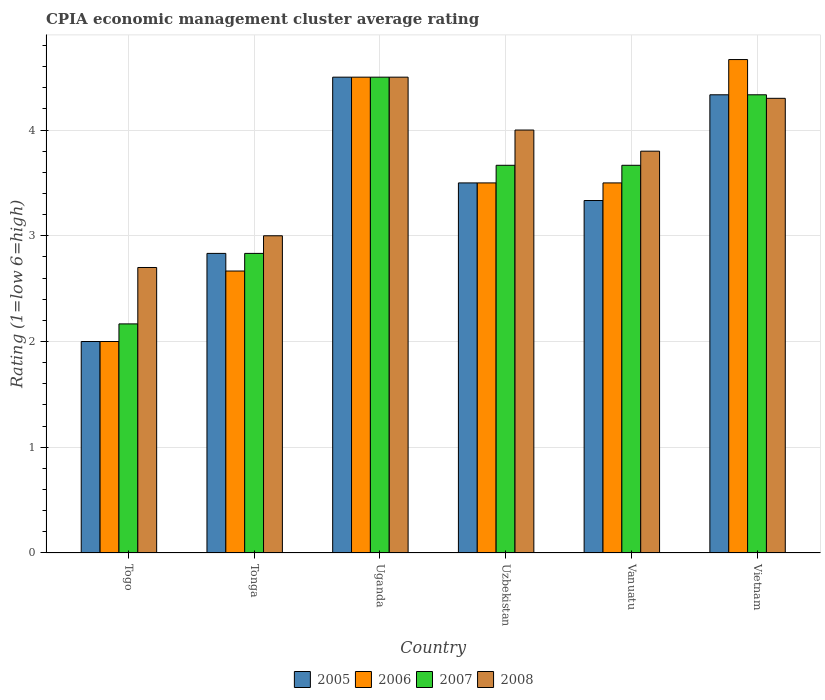Are the number of bars per tick equal to the number of legend labels?
Offer a terse response. Yes. How many bars are there on the 6th tick from the right?
Make the answer very short. 4. What is the label of the 6th group of bars from the left?
Offer a terse response. Vietnam. In how many cases, is the number of bars for a given country not equal to the number of legend labels?
Provide a short and direct response. 0. What is the CPIA rating in 2005 in Vietnam?
Offer a terse response. 4.33. Across all countries, what is the minimum CPIA rating in 2007?
Make the answer very short. 2.17. In which country was the CPIA rating in 2007 maximum?
Your response must be concise. Uganda. In which country was the CPIA rating in 2008 minimum?
Offer a terse response. Togo. What is the total CPIA rating in 2007 in the graph?
Your answer should be very brief. 21.17. What is the difference between the CPIA rating in 2007 in Uganda and that in Vietnam?
Your response must be concise. 0.17. What is the difference between the CPIA rating in 2006 in Vietnam and the CPIA rating in 2005 in Togo?
Give a very brief answer. 2.67. What is the average CPIA rating in 2005 per country?
Your answer should be compact. 3.42. What is the difference between the CPIA rating of/in 2006 and CPIA rating of/in 2007 in Uzbekistan?
Offer a terse response. -0.17. What is the ratio of the CPIA rating in 2007 in Tonga to that in Vanuatu?
Your response must be concise. 0.77. Is the difference between the CPIA rating in 2006 in Tonga and Vietnam greater than the difference between the CPIA rating in 2007 in Tonga and Vietnam?
Offer a terse response. No. What is the difference between the highest and the second highest CPIA rating in 2007?
Your answer should be very brief. -0.83. What is the difference between the highest and the lowest CPIA rating in 2006?
Offer a very short reply. 2.67. In how many countries, is the CPIA rating in 2008 greater than the average CPIA rating in 2008 taken over all countries?
Provide a succinct answer. 4. What does the 2nd bar from the left in Uzbekistan represents?
Offer a very short reply. 2006. What is the difference between two consecutive major ticks on the Y-axis?
Keep it short and to the point. 1. Does the graph contain grids?
Offer a very short reply. Yes. How many legend labels are there?
Offer a very short reply. 4. How are the legend labels stacked?
Provide a succinct answer. Horizontal. What is the title of the graph?
Your answer should be compact. CPIA economic management cluster average rating. What is the label or title of the X-axis?
Provide a succinct answer. Country. What is the Rating (1=low 6=high) of 2005 in Togo?
Offer a terse response. 2. What is the Rating (1=low 6=high) in 2007 in Togo?
Keep it short and to the point. 2.17. What is the Rating (1=low 6=high) of 2008 in Togo?
Ensure brevity in your answer.  2.7. What is the Rating (1=low 6=high) in 2005 in Tonga?
Offer a very short reply. 2.83. What is the Rating (1=low 6=high) in 2006 in Tonga?
Keep it short and to the point. 2.67. What is the Rating (1=low 6=high) in 2007 in Tonga?
Ensure brevity in your answer.  2.83. What is the Rating (1=low 6=high) of 2008 in Tonga?
Give a very brief answer. 3. What is the Rating (1=low 6=high) of 2005 in Uganda?
Give a very brief answer. 4.5. What is the Rating (1=low 6=high) in 2007 in Uzbekistan?
Offer a terse response. 3.67. What is the Rating (1=low 6=high) of 2008 in Uzbekistan?
Your answer should be compact. 4. What is the Rating (1=low 6=high) of 2005 in Vanuatu?
Give a very brief answer. 3.33. What is the Rating (1=low 6=high) in 2006 in Vanuatu?
Offer a terse response. 3.5. What is the Rating (1=low 6=high) in 2007 in Vanuatu?
Make the answer very short. 3.67. What is the Rating (1=low 6=high) in 2005 in Vietnam?
Your answer should be very brief. 4.33. What is the Rating (1=low 6=high) of 2006 in Vietnam?
Provide a short and direct response. 4.67. What is the Rating (1=low 6=high) in 2007 in Vietnam?
Ensure brevity in your answer.  4.33. Across all countries, what is the maximum Rating (1=low 6=high) of 2006?
Your answer should be very brief. 4.67. Across all countries, what is the maximum Rating (1=low 6=high) in 2007?
Your answer should be very brief. 4.5. Across all countries, what is the minimum Rating (1=low 6=high) of 2005?
Provide a short and direct response. 2. Across all countries, what is the minimum Rating (1=low 6=high) in 2007?
Give a very brief answer. 2.17. What is the total Rating (1=low 6=high) in 2005 in the graph?
Offer a terse response. 20.5. What is the total Rating (1=low 6=high) in 2006 in the graph?
Keep it short and to the point. 20.83. What is the total Rating (1=low 6=high) of 2007 in the graph?
Keep it short and to the point. 21.17. What is the total Rating (1=low 6=high) in 2008 in the graph?
Your response must be concise. 22.3. What is the difference between the Rating (1=low 6=high) of 2005 in Togo and that in Tonga?
Provide a short and direct response. -0.83. What is the difference between the Rating (1=low 6=high) of 2006 in Togo and that in Tonga?
Your response must be concise. -0.67. What is the difference between the Rating (1=low 6=high) of 2006 in Togo and that in Uganda?
Keep it short and to the point. -2.5. What is the difference between the Rating (1=low 6=high) of 2007 in Togo and that in Uganda?
Ensure brevity in your answer.  -2.33. What is the difference between the Rating (1=low 6=high) in 2005 in Togo and that in Uzbekistan?
Provide a short and direct response. -1.5. What is the difference between the Rating (1=low 6=high) in 2007 in Togo and that in Uzbekistan?
Give a very brief answer. -1.5. What is the difference between the Rating (1=low 6=high) in 2005 in Togo and that in Vanuatu?
Keep it short and to the point. -1.33. What is the difference between the Rating (1=low 6=high) of 2006 in Togo and that in Vanuatu?
Offer a very short reply. -1.5. What is the difference between the Rating (1=low 6=high) of 2007 in Togo and that in Vanuatu?
Make the answer very short. -1.5. What is the difference between the Rating (1=low 6=high) of 2005 in Togo and that in Vietnam?
Provide a succinct answer. -2.33. What is the difference between the Rating (1=low 6=high) of 2006 in Togo and that in Vietnam?
Your answer should be very brief. -2.67. What is the difference between the Rating (1=low 6=high) in 2007 in Togo and that in Vietnam?
Offer a terse response. -2.17. What is the difference between the Rating (1=low 6=high) in 2008 in Togo and that in Vietnam?
Make the answer very short. -1.6. What is the difference between the Rating (1=low 6=high) in 2005 in Tonga and that in Uganda?
Provide a short and direct response. -1.67. What is the difference between the Rating (1=low 6=high) of 2006 in Tonga and that in Uganda?
Ensure brevity in your answer.  -1.83. What is the difference between the Rating (1=low 6=high) of 2007 in Tonga and that in Uganda?
Offer a terse response. -1.67. What is the difference between the Rating (1=low 6=high) of 2008 in Tonga and that in Uganda?
Make the answer very short. -1.5. What is the difference between the Rating (1=low 6=high) of 2005 in Tonga and that in Vanuatu?
Your response must be concise. -0.5. What is the difference between the Rating (1=low 6=high) in 2007 in Tonga and that in Vanuatu?
Provide a short and direct response. -0.83. What is the difference between the Rating (1=low 6=high) of 2005 in Tonga and that in Vietnam?
Your answer should be very brief. -1.5. What is the difference between the Rating (1=low 6=high) in 2006 in Tonga and that in Vietnam?
Provide a short and direct response. -2. What is the difference between the Rating (1=low 6=high) in 2008 in Uganda and that in Uzbekistan?
Your answer should be very brief. 0.5. What is the difference between the Rating (1=low 6=high) in 2005 in Uganda and that in Vanuatu?
Offer a terse response. 1.17. What is the difference between the Rating (1=low 6=high) in 2008 in Uganda and that in Vanuatu?
Provide a succinct answer. 0.7. What is the difference between the Rating (1=low 6=high) of 2007 in Uganda and that in Vietnam?
Offer a very short reply. 0.17. What is the difference between the Rating (1=low 6=high) of 2008 in Uganda and that in Vietnam?
Make the answer very short. 0.2. What is the difference between the Rating (1=low 6=high) of 2005 in Uzbekistan and that in Vanuatu?
Make the answer very short. 0.17. What is the difference between the Rating (1=low 6=high) of 2007 in Uzbekistan and that in Vanuatu?
Provide a succinct answer. 0. What is the difference between the Rating (1=low 6=high) in 2008 in Uzbekistan and that in Vanuatu?
Keep it short and to the point. 0.2. What is the difference between the Rating (1=low 6=high) of 2005 in Uzbekistan and that in Vietnam?
Make the answer very short. -0.83. What is the difference between the Rating (1=low 6=high) in 2006 in Uzbekistan and that in Vietnam?
Keep it short and to the point. -1.17. What is the difference between the Rating (1=low 6=high) in 2007 in Uzbekistan and that in Vietnam?
Make the answer very short. -0.67. What is the difference between the Rating (1=low 6=high) of 2008 in Uzbekistan and that in Vietnam?
Offer a very short reply. -0.3. What is the difference between the Rating (1=low 6=high) of 2005 in Vanuatu and that in Vietnam?
Offer a terse response. -1. What is the difference between the Rating (1=low 6=high) of 2006 in Vanuatu and that in Vietnam?
Provide a succinct answer. -1.17. What is the difference between the Rating (1=low 6=high) in 2007 in Vanuatu and that in Vietnam?
Give a very brief answer. -0.67. What is the difference between the Rating (1=low 6=high) of 2008 in Vanuatu and that in Vietnam?
Ensure brevity in your answer.  -0.5. What is the difference between the Rating (1=low 6=high) of 2005 in Togo and the Rating (1=low 6=high) of 2006 in Tonga?
Provide a short and direct response. -0.67. What is the difference between the Rating (1=low 6=high) in 2005 in Togo and the Rating (1=low 6=high) in 2008 in Tonga?
Offer a very short reply. -1. What is the difference between the Rating (1=low 6=high) of 2006 in Togo and the Rating (1=low 6=high) of 2007 in Tonga?
Make the answer very short. -0.83. What is the difference between the Rating (1=low 6=high) of 2006 in Togo and the Rating (1=low 6=high) of 2008 in Tonga?
Keep it short and to the point. -1. What is the difference between the Rating (1=low 6=high) of 2007 in Togo and the Rating (1=low 6=high) of 2008 in Tonga?
Your answer should be compact. -0.83. What is the difference between the Rating (1=low 6=high) of 2005 in Togo and the Rating (1=low 6=high) of 2008 in Uganda?
Ensure brevity in your answer.  -2.5. What is the difference between the Rating (1=low 6=high) of 2006 in Togo and the Rating (1=low 6=high) of 2008 in Uganda?
Keep it short and to the point. -2.5. What is the difference between the Rating (1=low 6=high) of 2007 in Togo and the Rating (1=low 6=high) of 2008 in Uganda?
Your response must be concise. -2.33. What is the difference between the Rating (1=low 6=high) in 2005 in Togo and the Rating (1=low 6=high) in 2007 in Uzbekistan?
Your answer should be compact. -1.67. What is the difference between the Rating (1=low 6=high) of 2005 in Togo and the Rating (1=low 6=high) of 2008 in Uzbekistan?
Offer a very short reply. -2. What is the difference between the Rating (1=low 6=high) of 2006 in Togo and the Rating (1=low 6=high) of 2007 in Uzbekistan?
Ensure brevity in your answer.  -1.67. What is the difference between the Rating (1=low 6=high) of 2006 in Togo and the Rating (1=low 6=high) of 2008 in Uzbekistan?
Your answer should be very brief. -2. What is the difference between the Rating (1=low 6=high) in 2007 in Togo and the Rating (1=low 6=high) in 2008 in Uzbekistan?
Offer a terse response. -1.83. What is the difference between the Rating (1=low 6=high) in 2005 in Togo and the Rating (1=low 6=high) in 2006 in Vanuatu?
Your response must be concise. -1.5. What is the difference between the Rating (1=low 6=high) of 2005 in Togo and the Rating (1=low 6=high) of 2007 in Vanuatu?
Your answer should be compact. -1.67. What is the difference between the Rating (1=low 6=high) in 2006 in Togo and the Rating (1=low 6=high) in 2007 in Vanuatu?
Offer a very short reply. -1.67. What is the difference between the Rating (1=low 6=high) of 2007 in Togo and the Rating (1=low 6=high) of 2008 in Vanuatu?
Provide a short and direct response. -1.63. What is the difference between the Rating (1=low 6=high) in 2005 in Togo and the Rating (1=low 6=high) in 2006 in Vietnam?
Your answer should be very brief. -2.67. What is the difference between the Rating (1=low 6=high) of 2005 in Togo and the Rating (1=low 6=high) of 2007 in Vietnam?
Your response must be concise. -2.33. What is the difference between the Rating (1=low 6=high) of 2005 in Togo and the Rating (1=low 6=high) of 2008 in Vietnam?
Your answer should be very brief. -2.3. What is the difference between the Rating (1=low 6=high) in 2006 in Togo and the Rating (1=low 6=high) in 2007 in Vietnam?
Provide a succinct answer. -2.33. What is the difference between the Rating (1=low 6=high) in 2006 in Togo and the Rating (1=low 6=high) in 2008 in Vietnam?
Offer a terse response. -2.3. What is the difference between the Rating (1=low 6=high) in 2007 in Togo and the Rating (1=low 6=high) in 2008 in Vietnam?
Give a very brief answer. -2.13. What is the difference between the Rating (1=low 6=high) of 2005 in Tonga and the Rating (1=low 6=high) of 2006 in Uganda?
Ensure brevity in your answer.  -1.67. What is the difference between the Rating (1=low 6=high) of 2005 in Tonga and the Rating (1=low 6=high) of 2007 in Uganda?
Offer a terse response. -1.67. What is the difference between the Rating (1=low 6=high) in 2005 in Tonga and the Rating (1=low 6=high) in 2008 in Uganda?
Your answer should be compact. -1.67. What is the difference between the Rating (1=low 6=high) in 2006 in Tonga and the Rating (1=low 6=high) in 2007 in Uganda?
Your response must be concise. -1.83. What is the difference between the Rating (1=low 6=high) in 2006 in Tonga and the Rating (1=low 6=high) in 2008 in Uganda?
Your answer should be compact. -1.83. What is the difference between the Rating (1=low 6=high) of 2007 in Tonga and the Rating (1=low 6=high) of 2008 in Uganda?
Make the answer very short. -1.67. What is the difference between the Rating (1=low 6=high) of 2005 in Tonga and the Rating (1=low 6=high) of 2006 in Uzbekistan?
Ensure brevity in your answer.  -0.67. What is the difference between the Rating (1=low 6=high) of 2005 in Tonga and the Rating (1=low 6=high) of 2007 in Uzbekistan?
Keep it short and to the point. -0.83. What is the difference between the Rating (1=low 6=high) in 2005 in Tonga and the Rating (1=low 6=high) in 2008 in Uzbekistan?
Provide a succinct answer. -1.17. What is the difference between the Rating (1=low 6=high) in 2006 in Tonga and the Rating (1=low 6=high) in 2008 in Uzbekistan?
Your response must be concise. -1.33. What is the difference between the Rating (1=low 6=high) of 2007 in Tonga and the Rating (1=low 6=high) of 2008 in Uzbekistan?
Your response must be concise. -1.17. What is the difference between the Rating (1=low 6=high) of 2005 in Tonga and the Rating (1=low 6=high) of 2008 in Vanuatu?
Your answer should be compact. -0.97. What is the difference between the Rating (1=low 6=high) of 2006 in Tonga and the Rating (1=low 6=high) of 2008 in Vanuatu?
Offer a terse response. -1.13. What is the difference between the Rating (1=low 6=high) of 2007 in Tonga and the Rating (1=low 6=high) of 2008 in Vanuatu?
Offer a very short reply. -0.97. What is the difference between the Rating (1=low 6=high) of 2005 in Tonga and the Rating (1=low 6=high) of 2006 in Vietnam?
Offer a very short reply. -1.83. What is the difference between the Rating (1=low 6=high) in 2005 in Tonga and the Rating (1=low 6=high) in 2007 in Vietnam?
Your response must be concise. -1.5. What is the difference between the Rating (1=low 6=high) in 2005 in Tonga and the Rating (1=low 6=high) in 2008 in Vietnam?
Offer a terse response. -1.47. What is the difference between the Rating (1=low 6=high) of 2006 in Tonga and the Rating (1=low 6=high) of 2007 in Vietnam?
Ensure brevity in your answer.  -1.67. What is the difference between the Rating (1=low 6=high) in 2006 in Tonga and the Rating (1=low 6=high) in 2008 in Vietnam?
Offer a very short reply. -1.63. What is the difference between the Rating (1=low 6=high) in 2007 in Tonga and the Rating (1=low 6=high) in 2008 in Vietnam?
Your answer should be very brief. -1.47. What is the difference between the Rating (1=low 6=high) of 2005 in Uganda and the Rating (1=low 6=high) of 2006 in Uzbekistan?
Provide a succinct answer. 1. What is the difference between the Rating (1=low 6=high) of 2006 in Uganda and the Rating (1=low 6=high) of 2007 in Uzbekistan?
Provide a succinct answer. 0.83. What is the difference between the Rating (1=low 6=high) in 2006 in Uganda and the Rating (1=low 6=high) in 2008 in Uzbekistan?
Keep it short and to the point. 0.5. What is the difference between the Rating (1=low 6=high) in 2007 in Uganda and the Rating (1=low 6=high) in 2008 in Uzbekistan?
Offer a terse response. 0.5. What is the difference between the Rating (1=low 6=high) in 2005 in Uganda and the Rating (1=low 6=high) in 2007 in Vanuatu?
Your response must be concise. 0.83. What is the difference between the Rating (1=low 6=high) of 2006 in Uganda and the Rating (1=low 6=high) of 2007 in Vanuatu?
Ensure brevity in your answer.  0.83. What is the difference between the Rating (1=low 6=high) in 2006 in Uganda and the Rating (1=low 6=high) in 2008 in Vanuatu?
Give a very brief answer. 0.7. What is the difference between the Rating (1=low 6=high) in 2005 in Uganda and the Rating (1=low 6=high) in 2007 in Vietnam?
Your answer should be compact. 0.17. What is the difference between the Rating (1=low 6=high) in 2006 in Uganda and the Rating (1=low 6=high) in 2007 in Vietnam?
Your answer should be compact. 0.17. What is the difference between the Rating (1=low 6=high) in 2006 in Uganda and the Rating (1=low 6=high) in 2008 in Vietnam?
Your answer should be very brief. 0.2. What is the difference between the Rating (1=low 6=high) of 2007 in Uganda and the Rating (1=low 6=high) of 2008 in Vietnam?
Offer a very short reply. 0.2. What is the difference between the Rating (1=low 6=high) of 2005 in Uzbekistan and the Rating (1=low 6=high) of 2006 in Vanuatu?
Keep it short and to the point. 0. What is the difference between the Rating (1=low 6=high) of 2006 in Uzbekistan and the Rating (1=low 6=high) of 2007 in Vanuatu?
Provide a succinct answer. -0.17. What is the difference between the Rating (1=low 6=high) of 2006 in Uzbekistan and the Rating (1=low 6=high) of 2008 in Vanuatu?
Offer a very short reply. -0.3. What is the difference between the Rating (1=low 6=high) of 2007 in Uzbekistan and the Rating (1=low 6=high) of 2008 in Vanuatu?
Offer a terse response. -0.13. What is the difference between the Rating (1=low 6=high) in 2005 in Uzbekistan and the Rating (1=low 6=high) in 2006 in Vietnam?
Offer a terse response. -1.17. What is the difference between the Rating (1=low 6=high) in 2005 in Uzbekistan and the Rating (1=low 6=high) in 2008 in Vietnam?
Offer a very short reply. -0.8. What is the difference between the Rating (1=low 6=high) in 2006 in Uzbekistan and the Rating (1=low 6=high) in 2008 in Vietnam?
Provide a short and direct response. -0.8. What is the difference between the Rating (1=low 6=high) of 2007 in Uzbekistan and the Rating (1=low 6=high) of 2008 in Vietnam?
Offer a very short reply. -0.63. What is the difference between the Rating (1=low 6=high) in 2005 in Vanuatu and the Rating (1=low 6=high) in 2006 in Vietnam?
Keep it short and to the point. -1.33. What is the difference between the Rating (1=low 6=high) of 2005 in Vanuatu and the Rating (1=low 6=high) of 2008 in Vietnam?
Offer a terse response. -0.97. What is the difference between the Rating (1=low 6=high) in 2006 in Vanuatu and the Rating (1=low 6=high) in 2008 in Vietnam?
Give a very brief answer. -0.8. What is the difference between the Rating (1=low 6=high) in 2007 in Vanuatu and the Rating (1=low 6=high) in 2008 in Vietnam?
Provide a short and direct response. -0.63. What is the average Rating (1=low 6=high) in 2005 per country?
Your answer should be compact. 3.42. What is the average Rating (1=low 6=high) in 2006 per country?
Provide a short and direct response. 3.47. What is the average Rating (1=low 6=high) in 2007 per country?
Give a very brief answer. 3.53. What is the average Rating (1=low 6=high) in 2008 per country?
Your response must be concise. 3.72. What is the difference between the Rating (1=low 6=high) in 2005 and Rating (1=low 6=high) in 2008 in Togo?
Your answer should be compact. -0.7. What is the difference between the Rating (1=low 6=high) of 2007 and Rating (1=low 6=high) of 2008 in Togo?
Ensure brevity in your answer.  -0.53. What is the difference between the Rating (1=low 6=high) of 2005 and Rating (1=low 6=high) of 2007 in Tonga?
Provide a short and direct response. 0. What is the difference between the Rating (1=low 6=high) in 2006 and Rating (1=low 6=high) in 2007 in Tonga?
Your answer should be compact. -0.17. What is the difference between the Rating (1=low 6=high) of 2005 and Rating (1=low 6=high) of 2008 in Uganda?
Make the answer very short. 0. What is the difference between the Rating (1=low 6=high) of 2007 and Rating (1=low 6=high) of 2008 in Uganda?
Offer a very short reply. 0. What is the difference between the Rating (1=low 6=high) of 2005 and Rating (1=low 6=high) of 2007 in Uzbekistan?
Offer a very short reply. -0.17. What is the difference between the Rating (1=low 6=high) in 2005 and Rating (1=low 6=high) in 2008 in Uzbekistan?
Provide a succinct answer. -0.5. What is the difference between the Rating (1=low 6=high) of 2006 and Rating (1=low 6=high) of 2007 in Uzbekistan?
Your answer should be compact. -0.17. What is the difference between the Rating (1=low 6=high) of 2005 and Rating (1=low 6=high) of 2006 in Vanuatu?
Provide a short and direct response. -0.17. What is the difference between the Rating (1=low 6=high) in 2005 and Rating (1=low 6=high) in 2008 in Vanuatu?
Your answer should be compact. -0.47. What is the difference between the Rating (1=low 6=high) of 2006 and Rating (1=low 6=high) of 2007 in Vanuatu?
Make the answer very short. -0.17. What is the difference between the Rating (1=low 6=high) in 2006 and Rating (1=low 6=high) in 2008 in Vanuatu?
Offer a terse response. -0.3. What is the difference between the Rating (1=low 6=high) in 2007 and Rating (1=low 6=high) in 2008 in Vanuatu?
Offer a very short reply. -0.13. What is the difference between the Rating (1=low 6=high) in 2005 and Rating (1=low 6=high) in 2006 in Vietnam?
Provide a succinct answer. -0.33. What is the difference between the Rating (1=low 6=high) of 2005 and Rating (1=low 6=high) of 2007 in Vietnam?
Make the answer very short. 0. What is the difference between the Rating (1=low 6=high) in 2005 and Rating (1=low 6=high) in 2008 in Vietnam?
Make the answer very short. 0.03. What is the difference between the Rating (1=low 6=high) of 2006 and Rating (1=low 6=high) of 2007 in Vietnam?
Your answer should be very brief. 0.33. What is the difference between the Rating (1=low 6=high) of 2006 and Rating (1=low 6=high) of 2008 in Vietnam?
Your answer should be very brief. 0.37. What is the ratio of the Rating (1=low 6=high) in 2005 in Togo to that in Tonga?
Offer a terse response. 0.71. What is the ratio of the Rating (1=low 6=high) in 2007 in Togo to that in Tonga?
Provide a succinct answer. 0.76. What is the ratio of the Rating (1=low 6=high) of 2008 in Togo to that in Tonga?
Your answer should be compact. 0.9. What is the ratio of the Rating (1=low 6=high) in 2005 in Togo to that in Uganda?
Give a very brief answer. 0.44. What is the ratio of the Rating (1=low 6=high) of 2006 in Togo to that in Uganda?
Provide a succinct answer. 0.44. What is the ratio of the Rating (1=low 6=high) in 2007 in Togo to that in Uganda?
Give a very brief answer. 0.48. What is the ratio of the Rating (1=low 6=high) of 2005 in Togo to that in Uzbekistan?
Offer a very short reply. 0.57. What is the ratio of the Rating (1=low 6=high) of 2007 in Togo to that in Uzbekistan?
Provide a succinct answer. 0.59. What is the ratio of the Rating (1=low 6=high) in 2008 in Togo to that in Uzbekistan?
Offer a very short reply. 0.68. What is the ratio of the Rating (1=low 6=high) in 2007 in Togo to that in Vanuatu?
Ensure brevity in your answer.  0.59. What is the ratio of the Rating (1=low 6=high) of 2008 in Togo to that in Vanuatu?
Make the answer very short. 0.71. What is the ratio of the Rating (1=low 6=high) in 2005 in Togo to that in Vietnam?
Offer a terse response. 0.46. What is the ratio of the Rating (1=low 6=high) of 2006 in Togo to that in Vietnam?
Your response must be concise. 0.43. What is the ratio of the Rating (1=low 6=high) in 2008 in Togo to that in Vietnam?
Your answer should be compact. 0.63. What is the ratio of the Rating (1=low 6=high) of 2005 in Tonga to that in Uganda?
Make the answer very short. 0.63. What is the ratio of the Rating (1=low 6=high) in 2006 in Tonga to that in Uganda?
Keep it short and to the point. 0.59. What is the ratio of the Rating (1=low 6=high) in 2007 in Tonga to that in Uganda?
Your answer should be very brief. 0.63. What is the ratio of the Rating (1=low 6=high) in 2005 in Tonga to that in Uzbekistan?
Keep it short and to the point. 0.81. What is the ratio of the Rating (1=low 6=high) of 2006 in Tonga to that in Uzbekistan?
Provide a short and direct response. 0.76. What is the ratio of the Rating (1=low 6=high) of 2007 in Tonga to that in Uzbekistan?
Offer a terse response. 0.77. What is the ratio of the Rating (1=low 6=high) in 2006 in Tonga to that in Vanuatu?
Ensure brevity in your answer.  0.76. What is the ratio of the Rating (1=low 6=high) of 2007 in Tonga to that in Vanuatu?
Give a very brief answer. 0.77. What is the ratio of the Rating (1=low 6=high) of 2008 in Tonga to that in Vanuatu?
Your response must be concise. 0.79. What is the ratio of the Rating (1=low 6=high) of 2005 in Tonga to that in Vietnam?
Give a very brief answer. 0.65. What is the ratio of the Rating (1=low 6=high) in 2007 in Tonga to that in Vietnam?
Your answer should be very brief. 0.65. What is the ratio of the Rating (1=low 6=high) in 2008 in Tonga to that in Vietnam?
Ensure brevity in your answer.  0.7. What is the ratio of the Rating (1=low 6=high) of 2006 in Uganda to that in Uzbekistan?
Your answer should be compact. 1.29. What is the ratio of the Rating (1=low 6=high) of 2007 in Uganda to that in Uzbekistan?
Keep it short and to the point. 1.23. What is the ratio of the Rating (1=low 6=high) of 2005 in Uganda to that in Vanuatu?
Offer a very short reply. 1.35. What is the ratio of the Rating (1=low 6=high) of 2006 in Uganda to that in Vanuatu?
Your answer should be very brief. 1.29. What is the ratio of the Rating (1=low 6=high) of 2007 in Uganda to that in Vanuatu?
Your answer should be compact. 1.23. What is the ratio of the Rating (1=low 6=high) of 2008 in Uganda to that in Vanuatu?
Offer a very short reply. 1.18. What is the ratio of the Rating (1=low 6=high) of 2005 in Uganda to that in Vietnam?
Offer a very short reply. 1.04. What is the ratio of the Rating (1=low 6=high) in 2006 in Uganda to that in Vietnam?
Offer a terse response. 0.96. What is the ratio of the Rating (1=low 6=high) in 2007 in Uganda to that in Vietnam?
Offer a very short reply. 1.04. What is the ratio of the Rating (1=low 6=high) in 2008 in Uganda to that in Vietnam?
Your response must be concise. 1.05. What is the ratio of the Rating (1=low 6=high) of 2008 in Uzbekistan to that in Vanuatu?
Give a very brief answer. 1.05. What is the ratio of the Rating (1=low 6=high) in 2005 in Uzbekistan to that in Vietnam?
Your answer should be compact. 0.81. What is the ratio of the Rating (1=low 6=high) in 2006 in Uzbekistan to that in Vietnam?
Provide a succinct answer. 0.75. What is the ratio of the Rating (1=low 6=high) of 2007 in Uzbekistan to that in Vietnam?
Offer a very short reply. 0.85. What is the ratio of the Rating (1=low 6=high) of 2008 in Uzbekistan to that in Vietnam?
Ensure brevity in your answer.  0.93. What is the ratio of the Rating (1=low 6=high) of 2005 in Vanuatu to that in Vietnam?
Offer a terse response. 0.77. What is the ratio of the Rating (1=low 6=high) of 2007 in Vanuatu to that in Vietnam?
Provide a short and direct response. 0.85. What is the ratio of the Rating (1=low 6=high) in 2008 in Vanuatu to that in Vietnam?
Make the answer very short. 0.88. What is the difference between the highest and the second highest Rating (1=low 6=high) in 2005?
Your response must be concise. 0.17. What is the difference between the highest and the second highest Rating (1=low 6=high) of 2007?
Provide a short and direct response. 0.17. What is the difference between the highest and the lowest Rating (1=low 6=high) in 2006?
Offer a terse response. 2.67. What is the difference between the highest and the lowest Rating (1=low 6=high) of 2007?
Offer a terse response. 2.33. What is the difference between the highest and the lowest Rating (1=low 6=high) in 2008?
Give a very brief answer. 1.8. 